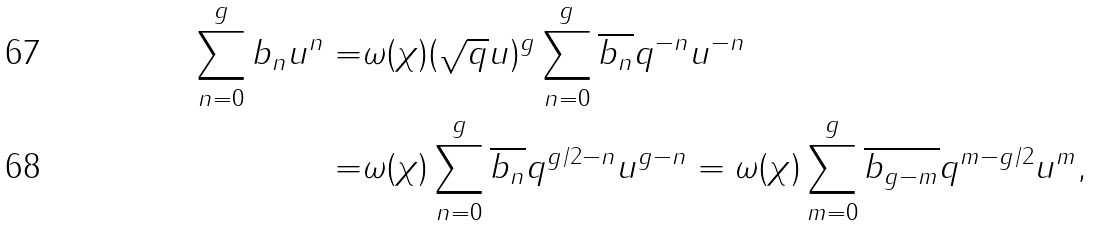Convert formula to latex. <formula><loc_0><loc_0><loc_500><loc_500>\sum _ { n = 0 } ^ { g } b _ { n } u ^ { n } = & \omega ( \chi ) ( \sqrt { q } u ) ^ { g } \sum _ { n = 0 } ^ { g } \overline { b _ { n } } q ^ { - n } u ^ { - n } \\ = & \omega ( \chi ) \sum _ { n = 0 } ^ { g } \overline { b _ { n } } q ^ { g / 2 - n } u ^ { g - n } = \omega ( \chi ) \sum _ { m = 0 } ^ { g } \overline { b _ { g - m } } q ^ { m - g / 2 } u ^ { m } ,</formula> 